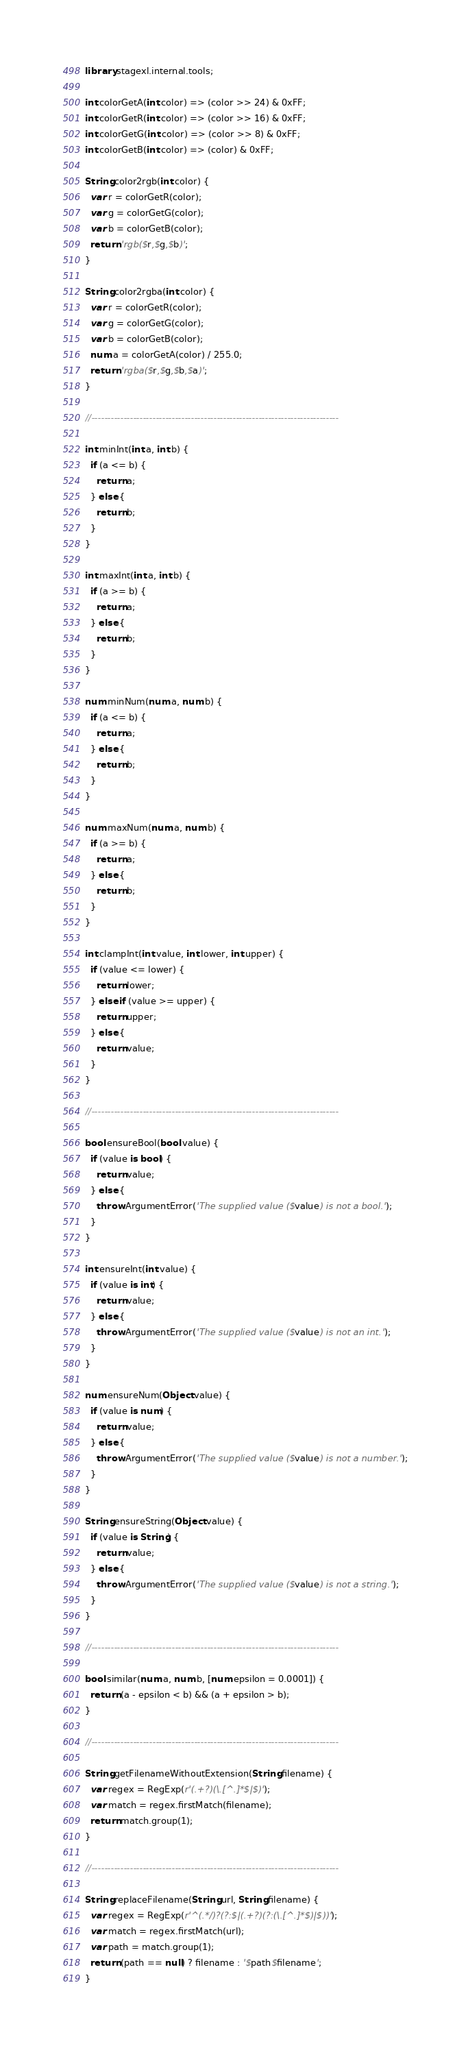<code> <loc_0><loc_0><loc_500><loc_500><_Dart_>library stagexl.internal.tools;

int colorGetA(int color) => (color >> 24) & 0xFF;
int colorGetR(int color) => (color >> 16) & 0xFF;
int colorGetG(int color) => (color >> 8) & 0xFF;
int colorGetB(int color) => (color) & 0xFF;

String color2rgb(int color) {
  var r = colorGetR(color);
  var g = colorGetG(color);
  var b = colorGetB(color);
  return 'rgb($r,$g,$b)';
}

String color2rgba(int color) {
  var r = colorGetR(color);
  var g = colorGetG(color);
  var b = colorGetB(color);
  num a = colorGetA(color) / 255.0;
  return 'rgba($r,$g,$b,$a)';
}

//-----------------------------------------------------------------------------

int minInt(int a, int b) {
  if (a <= b) {
    return a;
  } else {
    return b;
  }
}

int maxInt(int a, int b) {
  if (a >= b) {
    return a;
  } else {
    return b;
  }
}

num minNum(num a, num b) {
  if (a <= b) {
    return a;
  } else {
    return b;
  }
}

num maxNum(num a, num b) {
  if (a >= b) {
    return a;
  } else {
    return b;
  }
}

int clampInt(int value, int lower, int upper) {
  if (value <= lower) {
    return lower;
  } else if (value >= upper) {
    return upper;
  } else {
    return value;
  }
}

//-----------------------------------------------------------------------------

bool ensureBool(bool value) {
  if (value is bool) {
    return value;
  } else {
    throw ArgumentError('The supplied value ($value) is not a bool.');
  }
}

int ensureInt(int value) {
  if (value is int) {
    return value;
  } else {
    throw ArgumentError('The supplied value ($value) is not an int.');
  }
}

num ensureNum(Object value) {
  if (value is num) {
    return value;
  } else {
    throw ArgumentError('The supplied value ($value) is not a number.');
  }
}

String ensureString(Object value) {
  if (value is String) {
    return value;
  } else {
    throw ArgumentError('The supplied value ($value) is not a string.');
  }
}

//-----------------------------------------------------------------------------

bool similar(num a, num b, [num epsilon = 0.0001]) {
  return (a - epsilon < b) && (a + epsilon > b);
}

//-----------------------------------------------------------------------------

String getFilenameWithoutExtension(String filename) {
  var regex = RegExp(r'(.+?)(\.[^.]*$|$)');
  var match = regex.firstMatch(filename);
  return match.group(1);
}

//-----------------------------------------------------------------------------

String replaceFilename(String url, String filename) {
  var regex = RegExp(r'^(.*/)?(?:$|(.+?)(?:(\.[^.]*$)|$))');
  var match = regex.firstMatch(url);
  var path = match.group(1);
  return (path == null) ? filename : '$path$filename';
}
</code> 